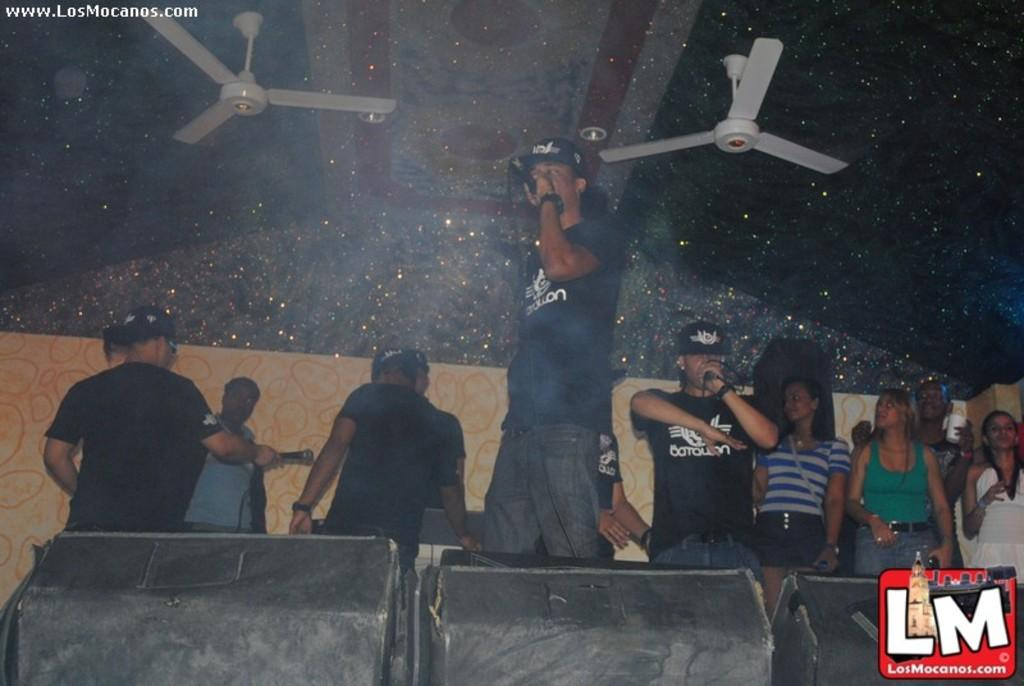What are the persons in the image doing? The persons in the image are singing on the mic. Where are the persons standing in the image? There are persons standing on the stage on the right side of the image. What can be seen on the ceiling in the image? There are fans on the ceiling in the image. What type of bean is being used as a prop in the image? There is no bean present in the image; it features persons singing on the mic and standing on the stage. 